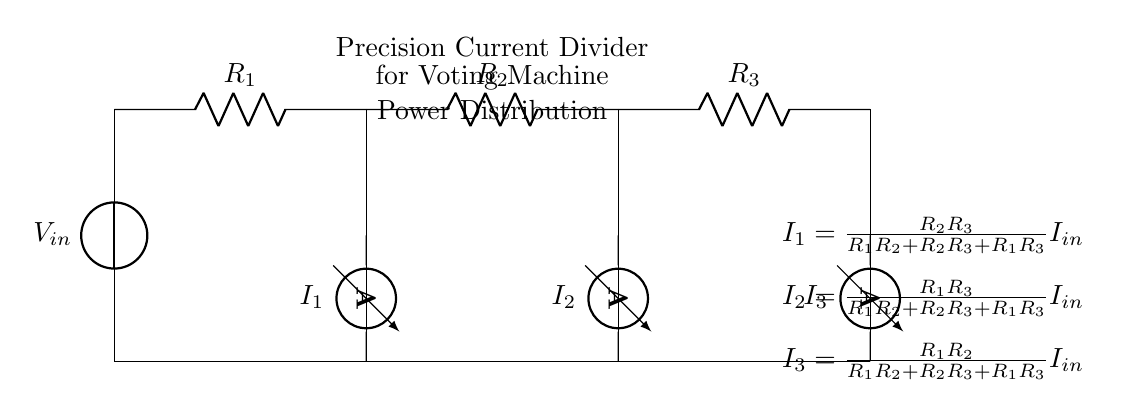What is the input voltage in this circuit? The input voltage is labeled as V_in, which indicates the source voltage for the circuit.
Answer: V_in What are the three resistances in the circuit? The circuit has three resistors labeled as R_1, R_2, and R_3, which are positioned in series.
Answer: R_1, R_2, R_3 What is the total current flowing into the divider? The total current flowing into the divider is I_in, which can be interpreted from the circuit and is the input current for the overall system.
Answer: I_in How is the current I_1 calculated in this circuit? I_1 is calculated using the formula I_1 = (R_2R_3) / (R_1R_2 + R_2R_3 + R_1R_3) multiplied by I_in. This reflects the current division rule applied in this circuit.
Answer: R_2R_3 / (R_1R_2 + R_2R_3 + R_1R_3) I_in Which component measures the current I_2 in the circuit? The component measuring the current I_2 is an ammeter, which is connected in parallel to the resistor R_2.
Answer: Ammeter What is the purpose of using a precision current divider in voting machines? The purpose is to ensure accurate voltage and current distribution among counting systems, which is essential for reliable vote counting.
Answer: Accurate vote counting 